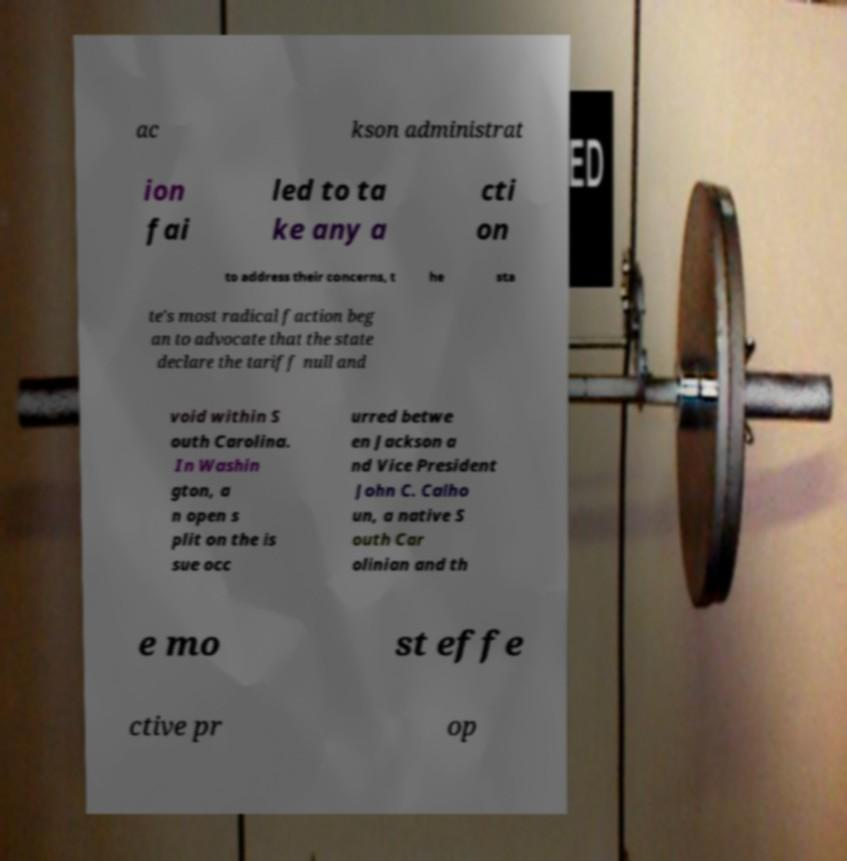Can you read and provide the text displayed in the image?This photo seems to have some interesting text. Can you extract and type it out for me? ac kson administrat ion fai led to ta ke any a cti on to address their concerns, t he sta te's most radical faction beg an to advocate that the state declare the tariff null and void within S outh Carolina. In Washin gton, a n open s plit on the is sue occ urred betwe en Jackson a nd Vice President John C. Calho un, a native S outh Car olinian and th e mo st effe ctive pr op 